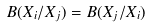Convert formula to latex. <formula><loc_0><loc_0><loc_500><loc_500>B ( X _ { i } / X _ { j } ) = B ( X _ { j } / X _ { i } )</formula> 